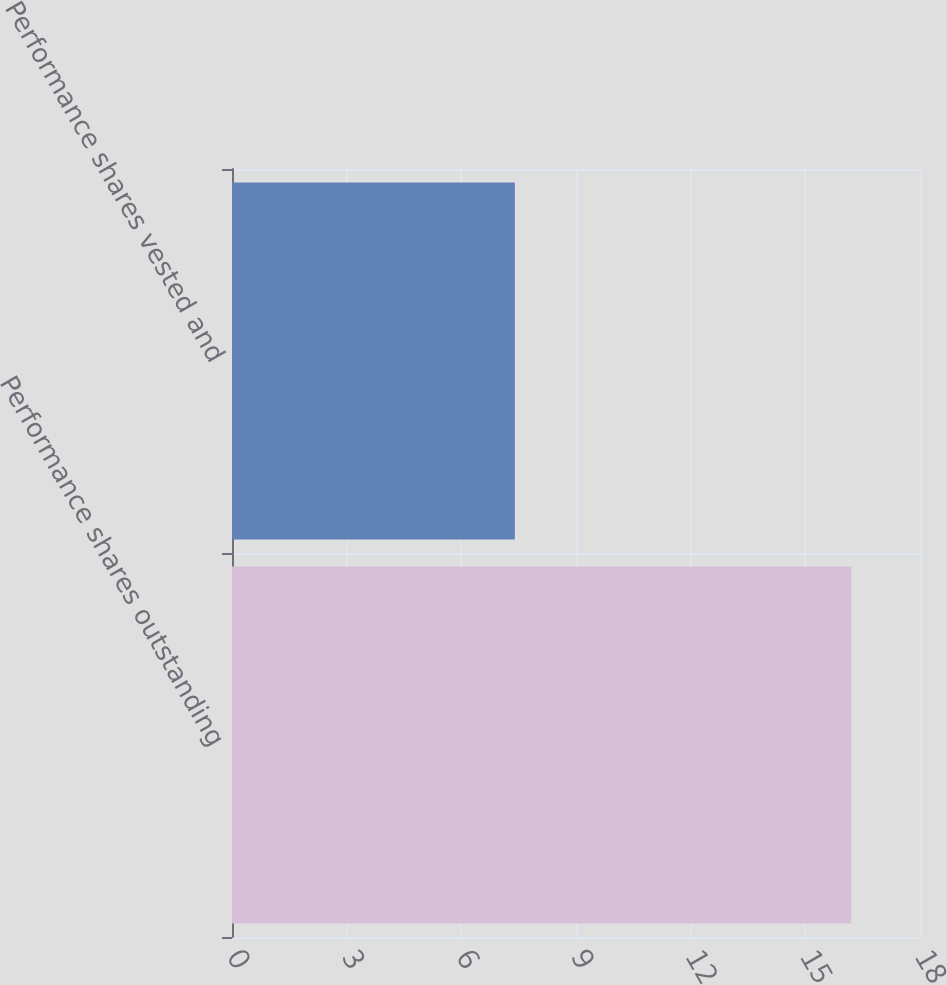<chart> <loc_0><loc_0><loc_500><loc_500><bar_chart><fcel>Performance shares outstanding<fcel>Performance shares vested and<nl><fcel>16.2<fcel>7.4<nl></chart> 